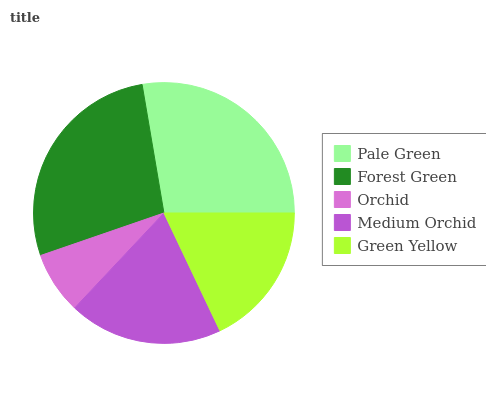Is Orchid the minimum?
Answer yes or no. Yes. Is Pale Green the maximum?
Answer yes or no. Yes. Is Forest Green the minimum?
Answer yes or no. No. Is Forest Green the maximum?
Answer yes or no. No. Is Pale Green greater than Forest Green?
Answer yes or no. Yes. Is Forest Green less than Pale Green?
Answer yes or no. Yes. Is Forest Green greater than Pale Green?
Answer yes or no. No. Is Pale Green less than Forest Green?
Answer yes or no. No. Is Medium Orchid the high median?
Answer yes or no. Yes. Is Medium Orchid the low median?
Answer yes or no. Yes. Is Orchid the high median?
Answer yes or no. No. Is Forest Green the low median?
Answer yes or no. No. 